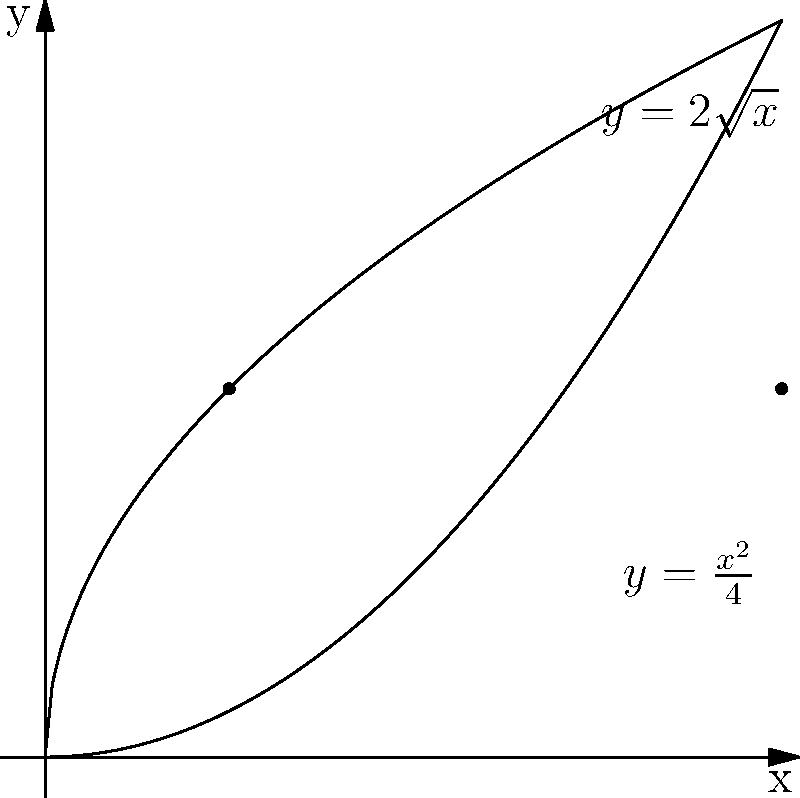A coffee shop introduces a new pastry shaped like a solid of revolution. The pastry's cross-section is formed by rotating the region bounded by $y=2\sqrt{x}$, $y=\frac{x^2}{4}$, and the y-axis around the y-axis. What is the volume of this pastry in cubic units? To find the volume of the solid of revolution, we'll use the washer method:

1) First, we need to find the points of intersection of the two curves:
   $2\sqrt{x} = \frac{x^2}{4}$
   $16x = x^4$
   $x^4 - 16x = 0$
   $x(x^3 - 16) = 0$
   $x = 0$ or $x = 4$ (since $\sqrt[3]{16} = 2.52 < 4$)

2) The volume is given by the formula:
   $V = \pi \int_0^4 [(2\sqrt{x})^2 - (\frac{x^2}{4})^2] dx$

3) Simplify the integrand:
   $V = \pi \int_0^4 [4x - \frac{x^4}{16}] dx$

4) Integrate:
   $V = \pi [\frac{4x^2}{2} - \frac{x^5}{80}]_0^4$

5) Evaluate the limits:
   $V = \pi [(32 - \frac{1024}{80}) - (0 - 0)]$
   $V = \pi [32 - \frac{64}{5}]$
   $V = \pi [\frac{160}{5} - \frac{64}{5}]$
   $V = \pi [\frac{96}{5}]$
   $V = \frac{96\pi}{5}$

Therefore, the volume of the pastry is $\frac{96\pi}{5}$ cubic units.
Answer: $\frac{96\pi}{5}$ cubic units 